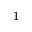Convert formula to latex. <formula><loc_0><loc_0><loc_500><loc_500>- 1</formula> 